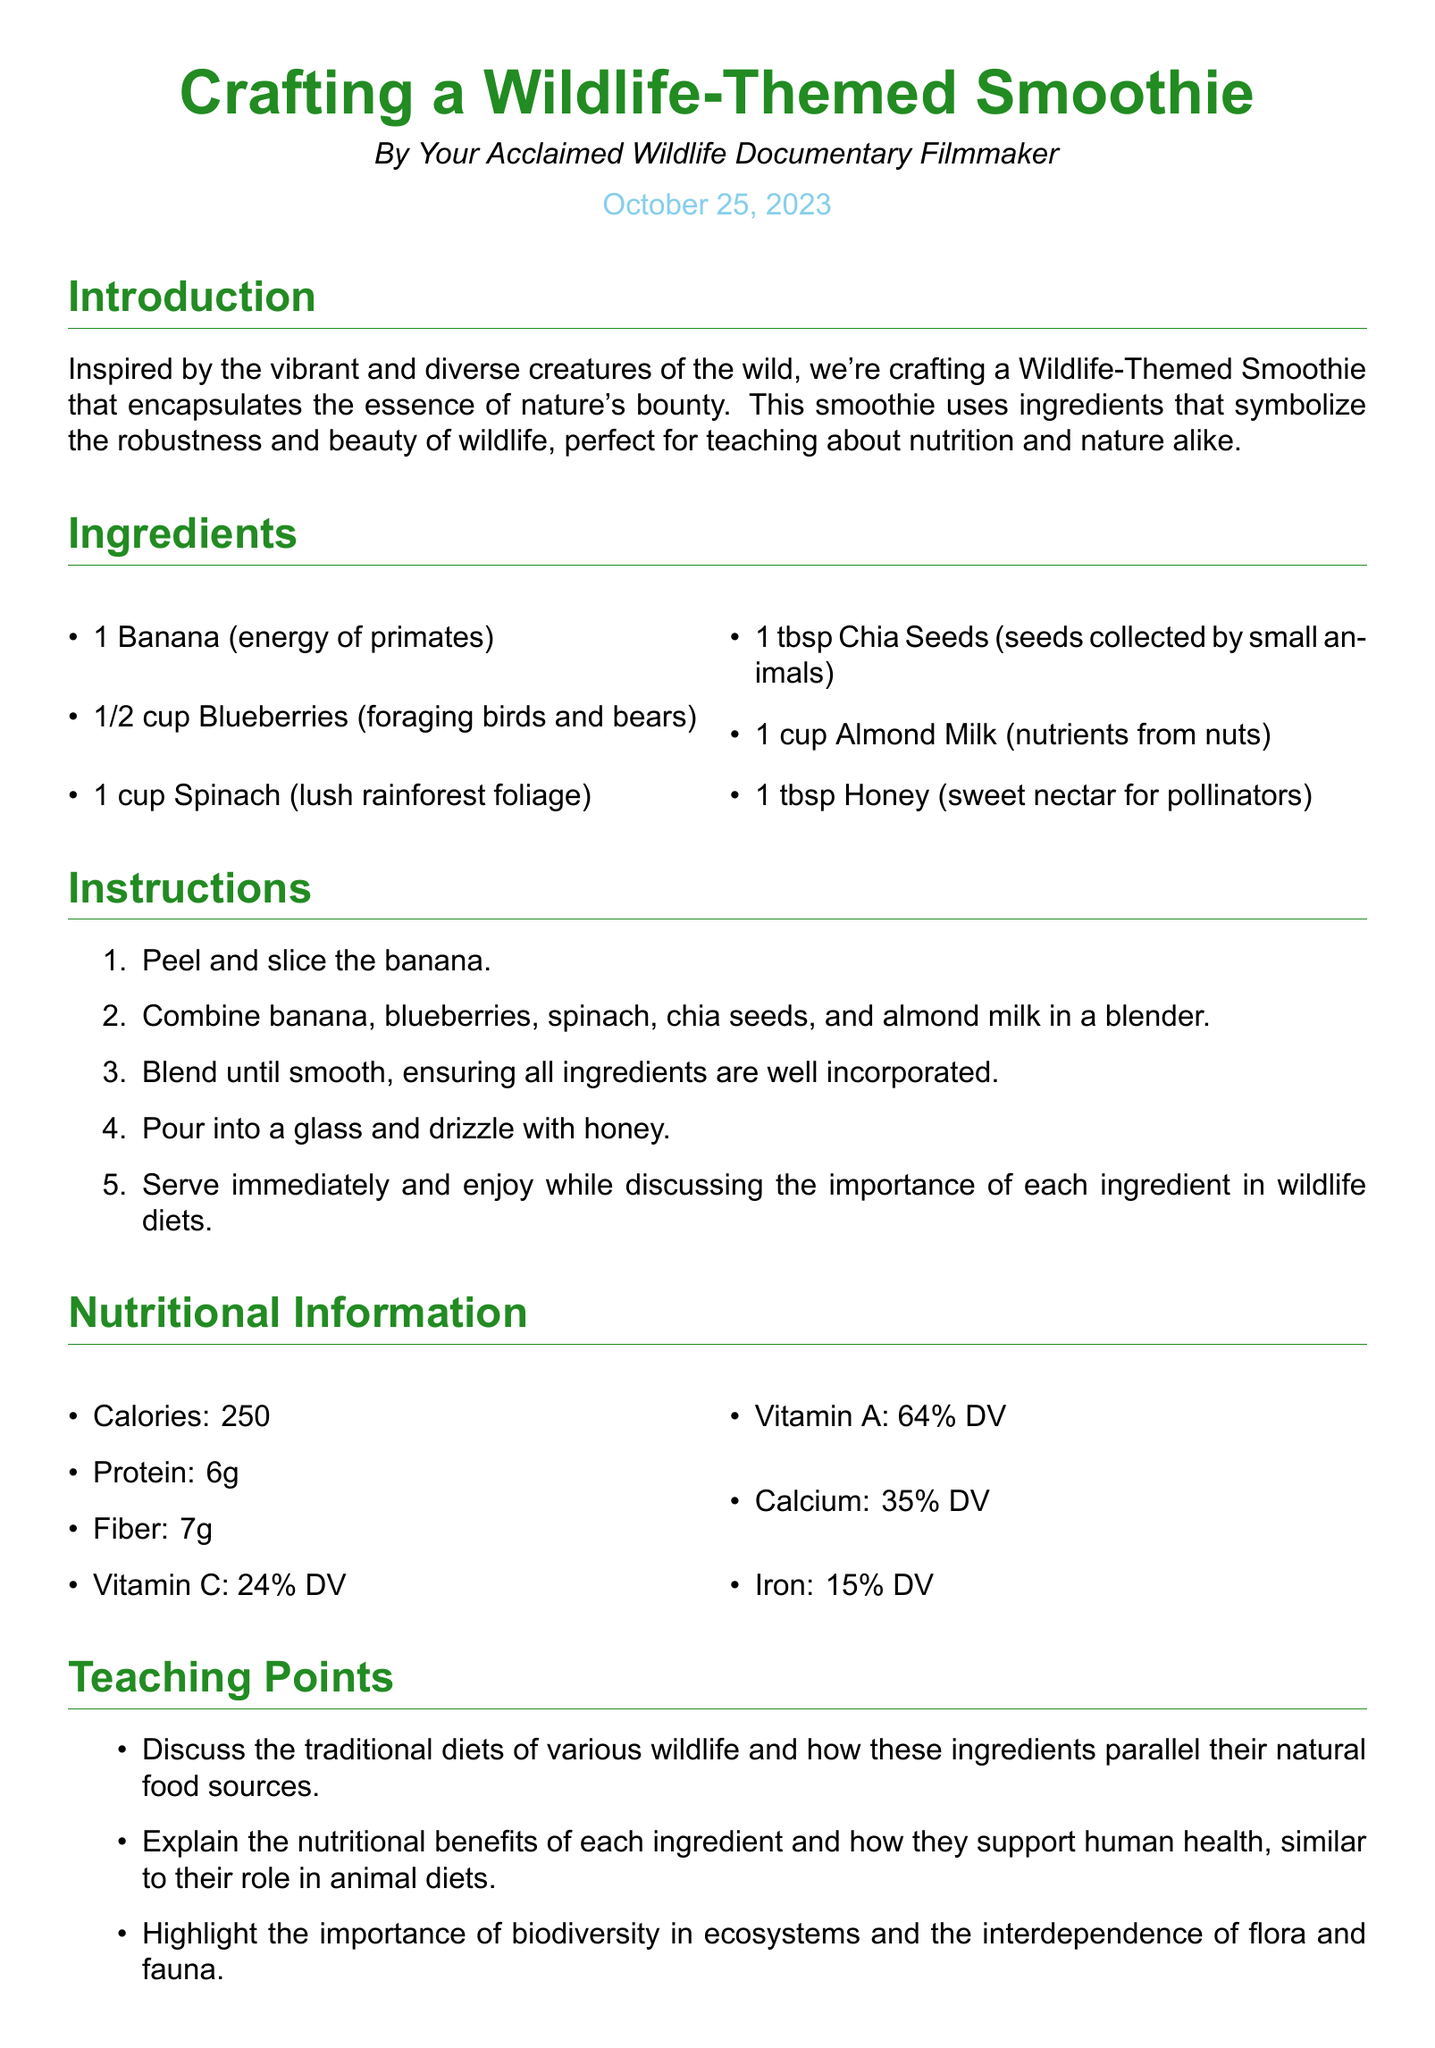What is the main theme of the smoothie? The main theme of the smoothie is inspired by wildlife and nature, focusing on ingredients that symbolize the essence of diverse creatures.
Answer: Wildlife What ingredient represents the energy of primates? The ingredient that represents the energy of primates is a banana, mentioned in the ingredients section.
Answer: Banana How many cups of spinach are used? The recipe specifies that 1 cup of spinach is used as one of the ingredients.
Answer: 1 cup What is the Vitamin C percentage of daily value provided by the smoothie? The smoothie provides 24% of the daily value for Vitamin C, as stated in the nutritional information.
Answer: 24% DV What type of milk is used in the recipe? The recipe uses almond milk as the liquid base for the smoothie.
Answer: Almond Milk How many tablespoons of chia seeds are included? The recipe calls for 1 tablespoon of chia seeds among the ingredients.
Answer: 1 tbsp What is one teaching point mentioned in the document? One teaching point is to discuss the traditional diets of various wildlife and how the ingredients parallel their natural food sources.
Answer: Traditional diets What is the total calorie count of the smoothie? The total calorie count for the smoothie is stated as 250 calories in the nutritional information.
Answer: 250 What is the instruction to serve the smoothie? The instruction states to pour into a glass and drizzle with honey before serving.
Answer: Pour into a glass and drizzle with honey 